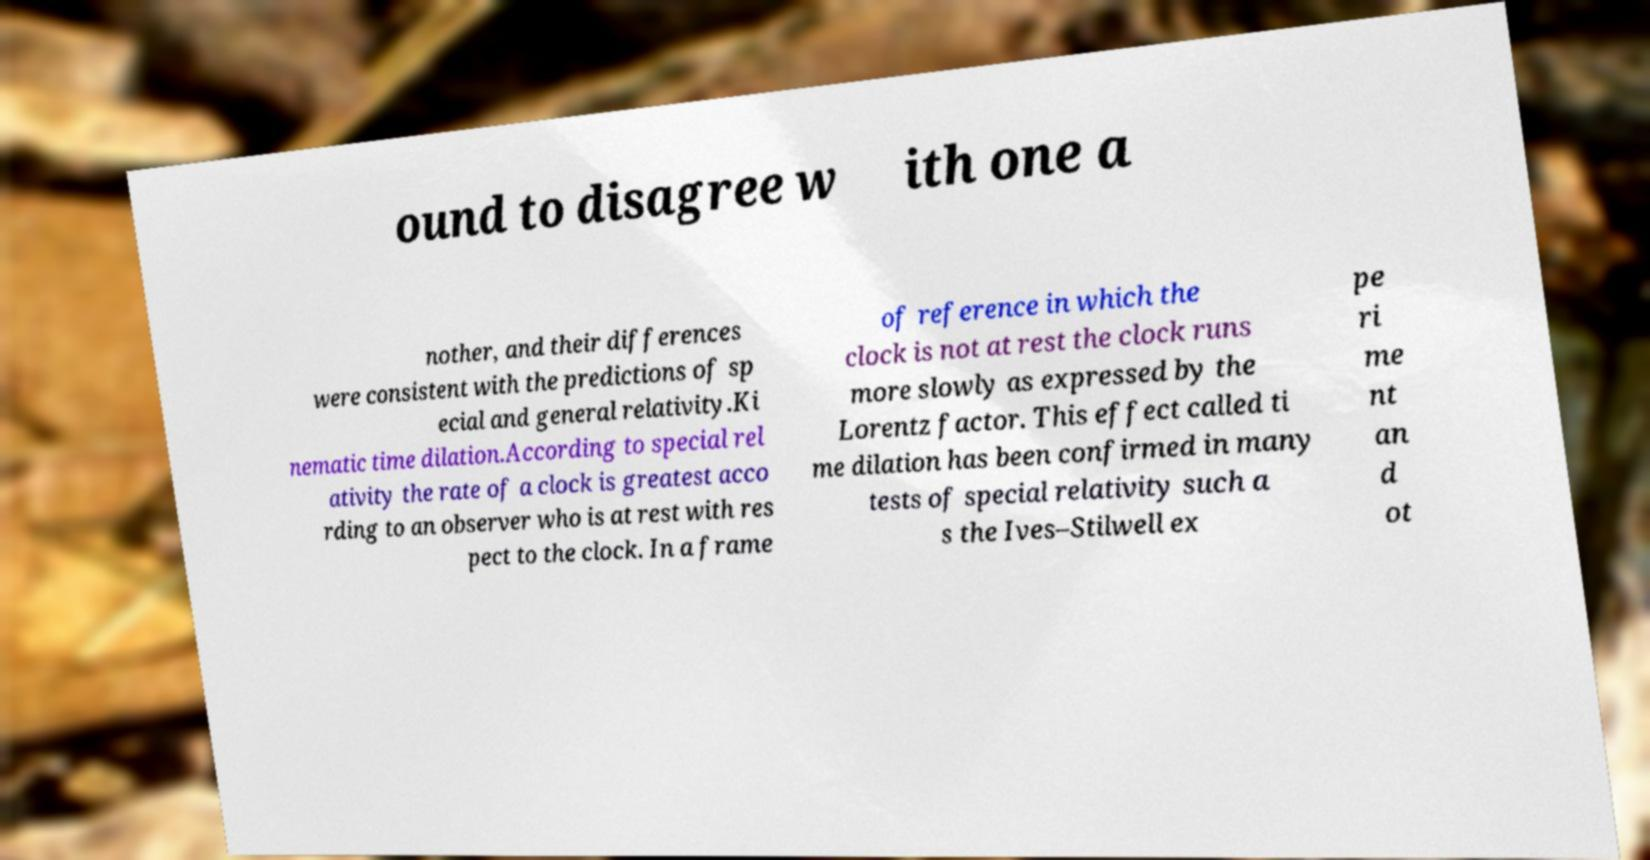Please identify and transcribe the text found in this image. ound to disagree w ith one a nother, and their differences were consistent with the predictions of sp ecial and general relativity.Ki nematic time dilation.According to special rel ativity the rate of a clock is greatest acco rding to an observer who is at rest with res pect to the clock. In a frame of reference in which the clock is not at rest the clock runs more slowly as expressed by the Lorentz factor. This effect called ti me dilation has been confirmed in many tests of special relativity such a s the Ives–Stilwell ex pe ri me nt an d ot 